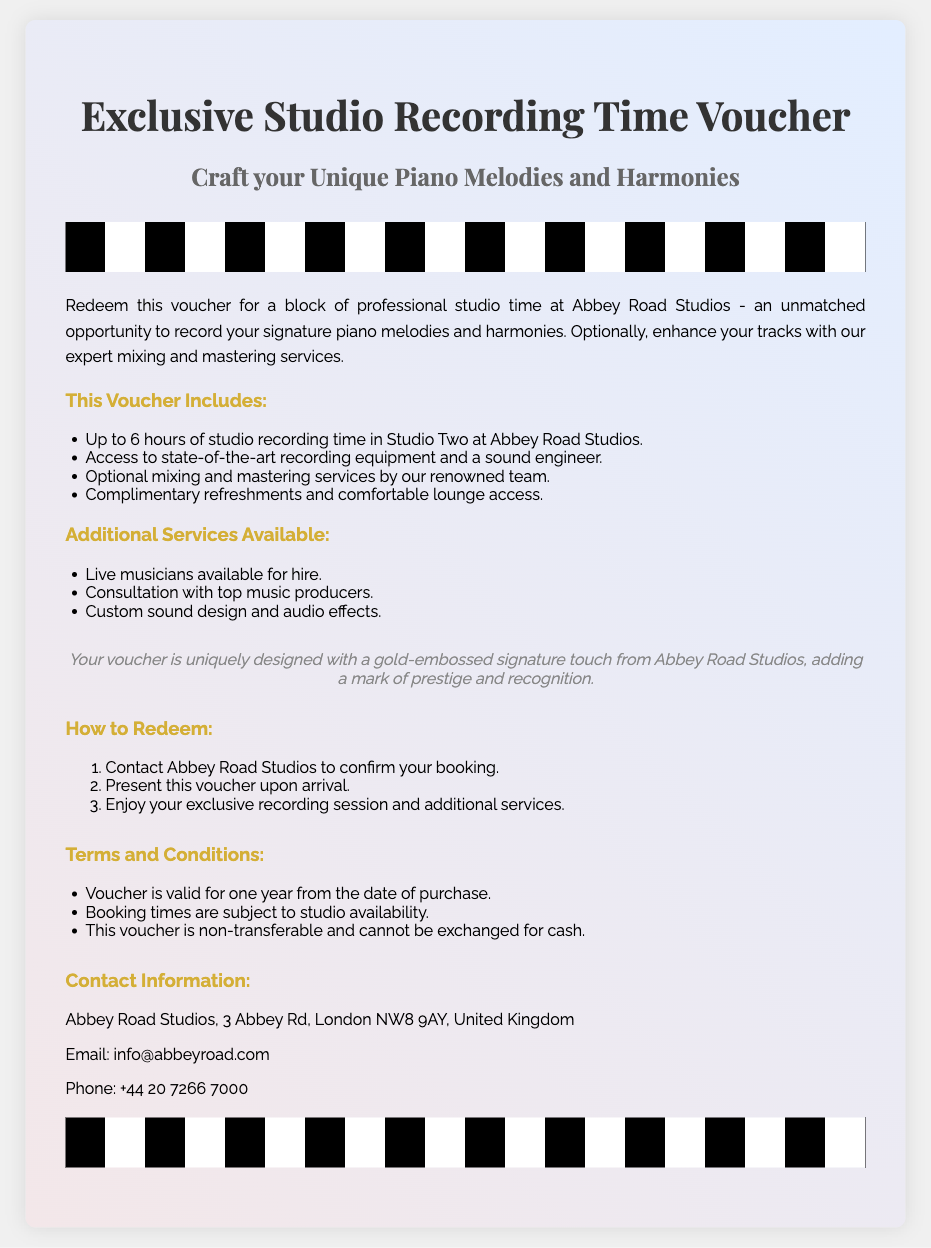What is the name of the studio? The studio where the recording time voucher can be redeemed is Abbey Road Studios.
Answer: Abbey Road Studios How many hours of studio recording time does the voucher include? The voucher specifies that it includes up to 6 hours of studio recording time.
Answer: 6 hours What services can be optionally added to the voucher? The document lists optional mixing and mastering services that can enhance the tracks.
Answer: Mixing and mastering What is the validity period of the voucher? The voucher is valid for one year from the date of purchase.
Answer: One year What is included in the complimentary offerings during the studio time? It mentions complimentary refreshments and access to a comfortable lounge as part of the voucher offerings.
Answer: Refreshments and lounge access How are bookings for the voucher confirmed? The process to redeem the voucher includes contacting Abbey Road Studios to confirm the booking.
Answer: Contact Abbey Road Studios Is the voucher transferable? The terms state that the voucher is non-transferable, which indicates it cannot be passed to another person.
Answer: Non-transferable What additional services are listed that can be accessed using this voucher? The document mentions live musicians available for hire as an additional service that can be accessed.
Answer: Live musicians Which type of touch does the voucher have to signify its prestige? The voucher is uniquely designed with a gold-embossed signature touch from Abbey Road Studios.
Answer: Gold-embossed signature 